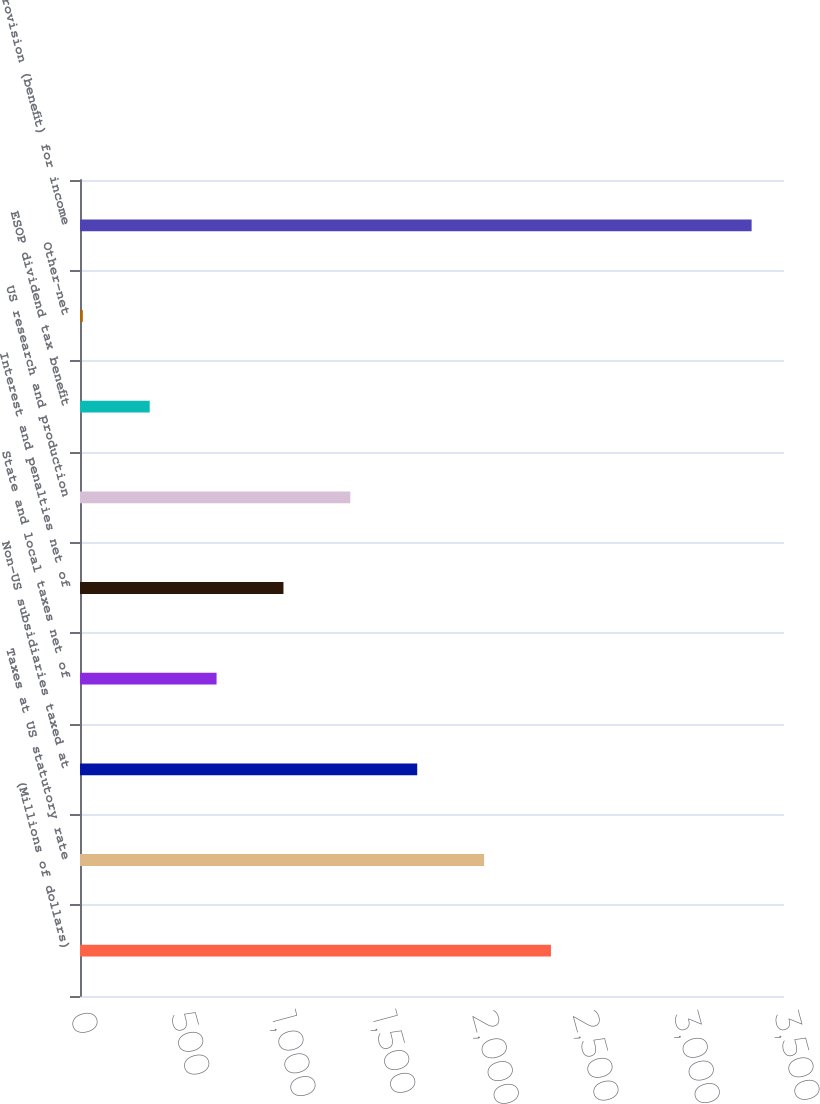<chart> <loc_0><loc_0><loc_500><loc_500><bar_chart><fcel>(Millions of dollars)<fcel>Taxes at US statutory rate<fcel>Non-US subsidiaries taxed at<fcel>State and local taxes net of<fcel>Interest and penalties net of<fcel>US research and production<fcel>ESOP dividend tax benefit<fcel>Other-net<fcel>Provision (benefit) for income<nl><fcel>2341.5<fcel>2009<fcel>1676.5<fcel>679<fcel>1011.5<fcel>1344<fcel>346.5<fcel>14<fcel>3339<nl></chart> 